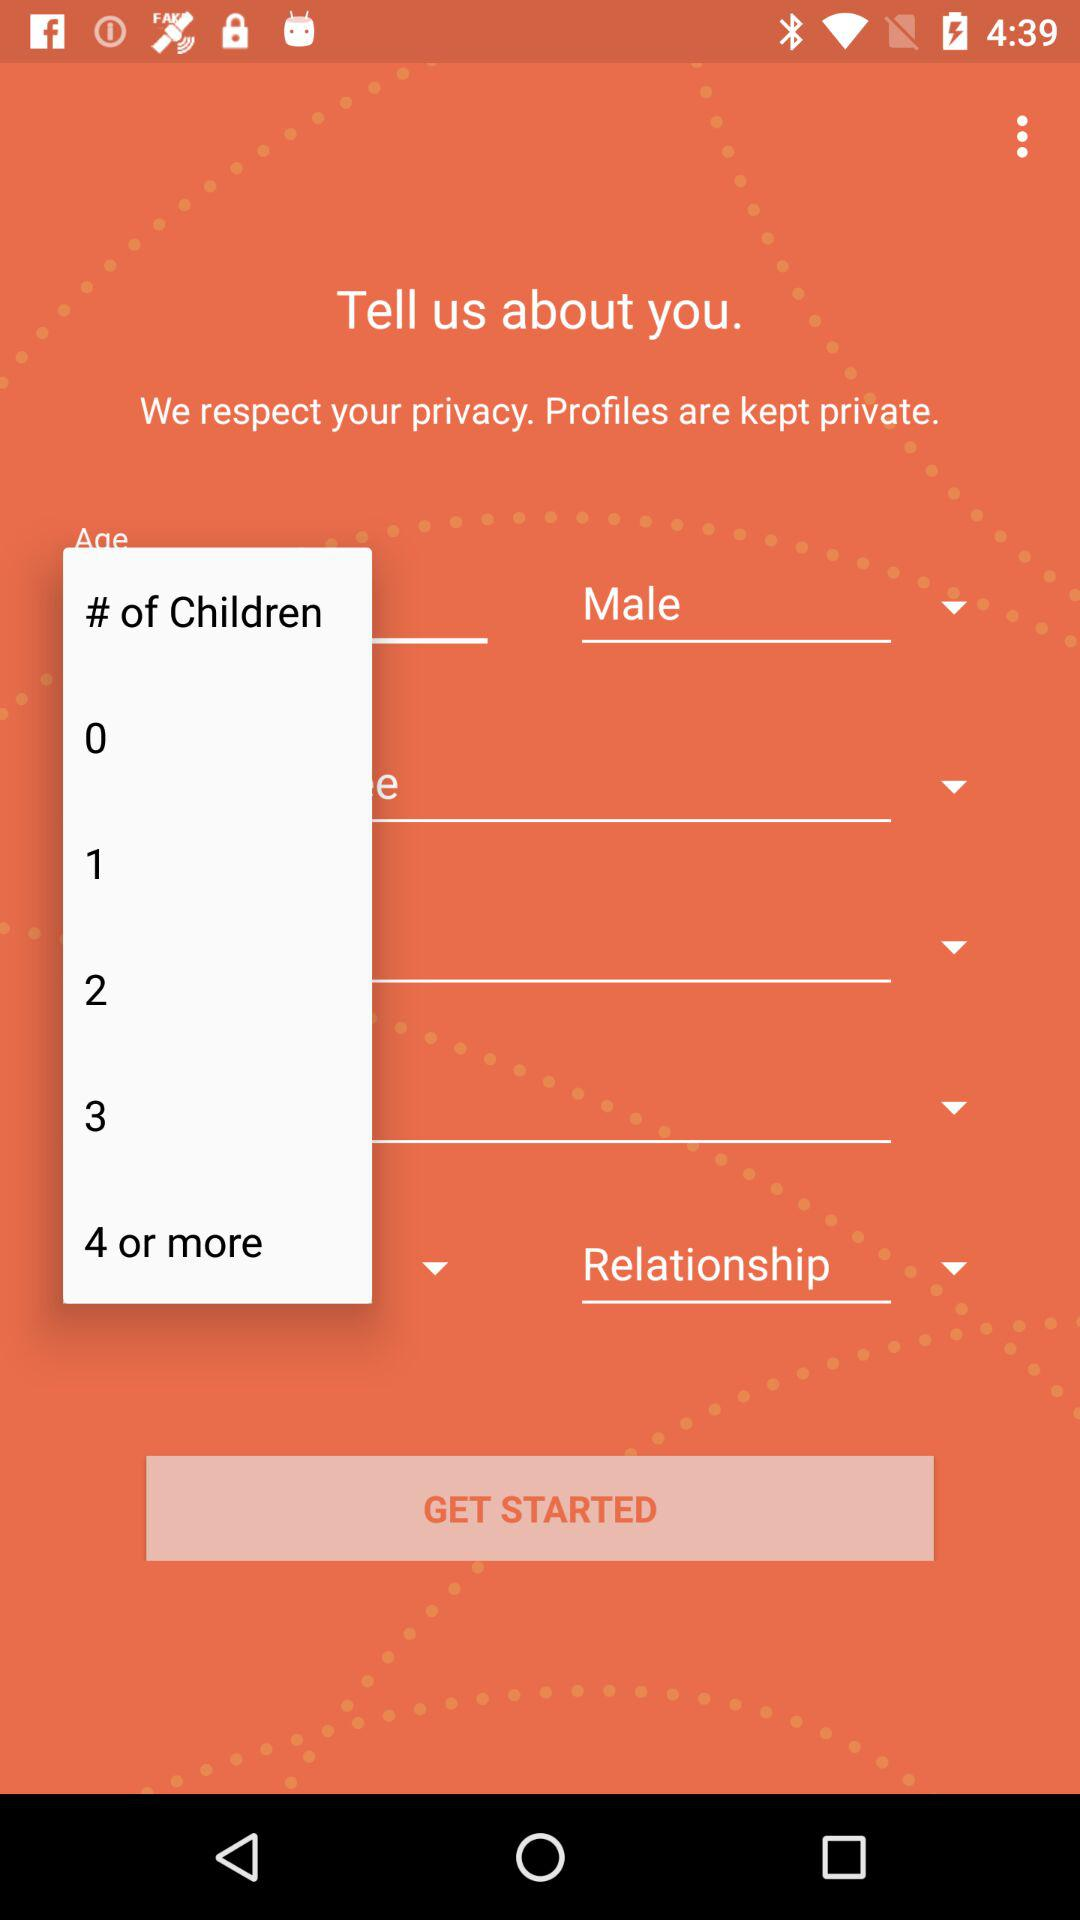Which gender is selected? The selected gender is male. 